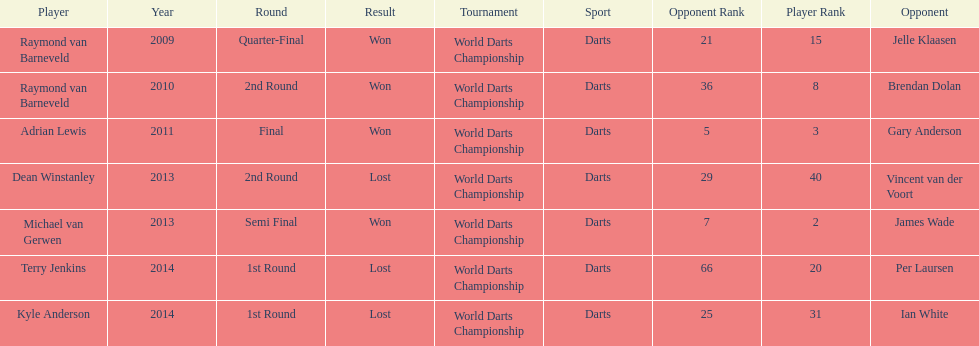Other than kyle anderson, who else lost in 2014? Terry Jenkins. 